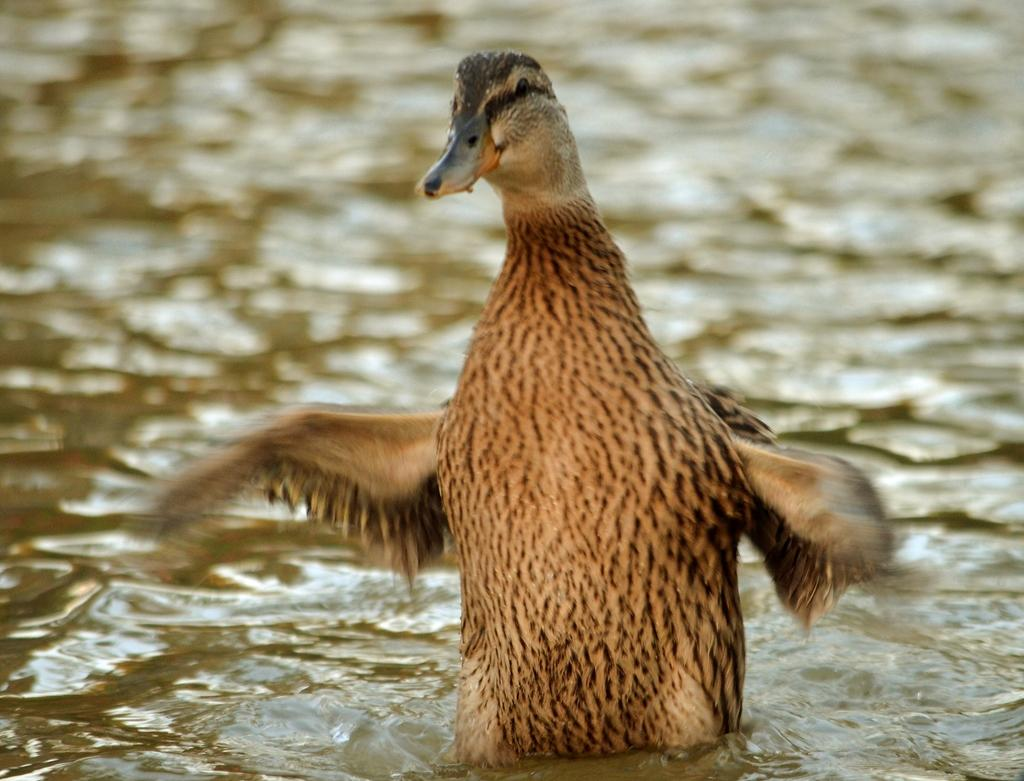What type of animal can be seen in the image? There is a bird in the image. Where is the bird located in the image? The bird is standing in the water. What colors can be observed on the bird? The bird has brown and black coloring. What is visible in the background of the image? A: Water is visible in the image. How does the bird kick the soccer ball in the image? There is no soccer ball present in the image, so the bird cannot kick a soccer ball. 